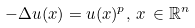Convert formula to latex. <formula><loc_0><loc_0><loc_500><loc_500>- \Delta u ( x ) = u ( x ) ^ { p } , \, x \, \in \mathbb { R } ^ { n }</formula> 